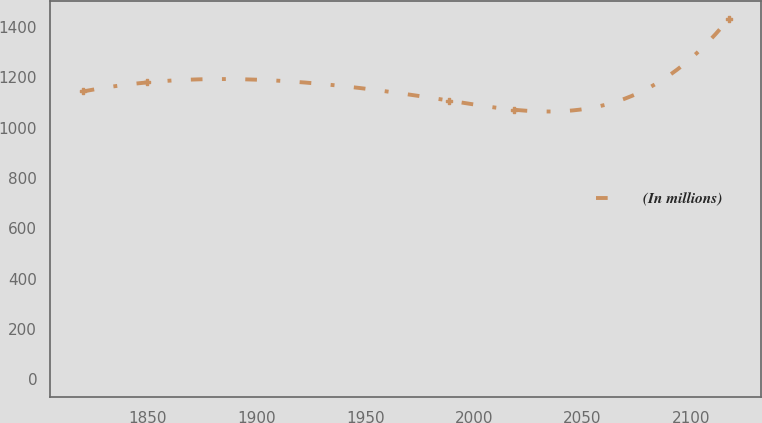Convert chart to OTSL. <chart><loc_0><loc_0><loc_500><loc_500><line_chart><ecel><fcel>(In millions)<nl><fcel>1819.95<fcel>1144.24<nl><fcel>1849.69<fcel>1180.41<nl><fcel>1988.62<fcel>1108.07<nl><fcel>2018.36<fcel>1071.9<nl><fcel>2117.33<fcel>1433.62<nl></chart> 